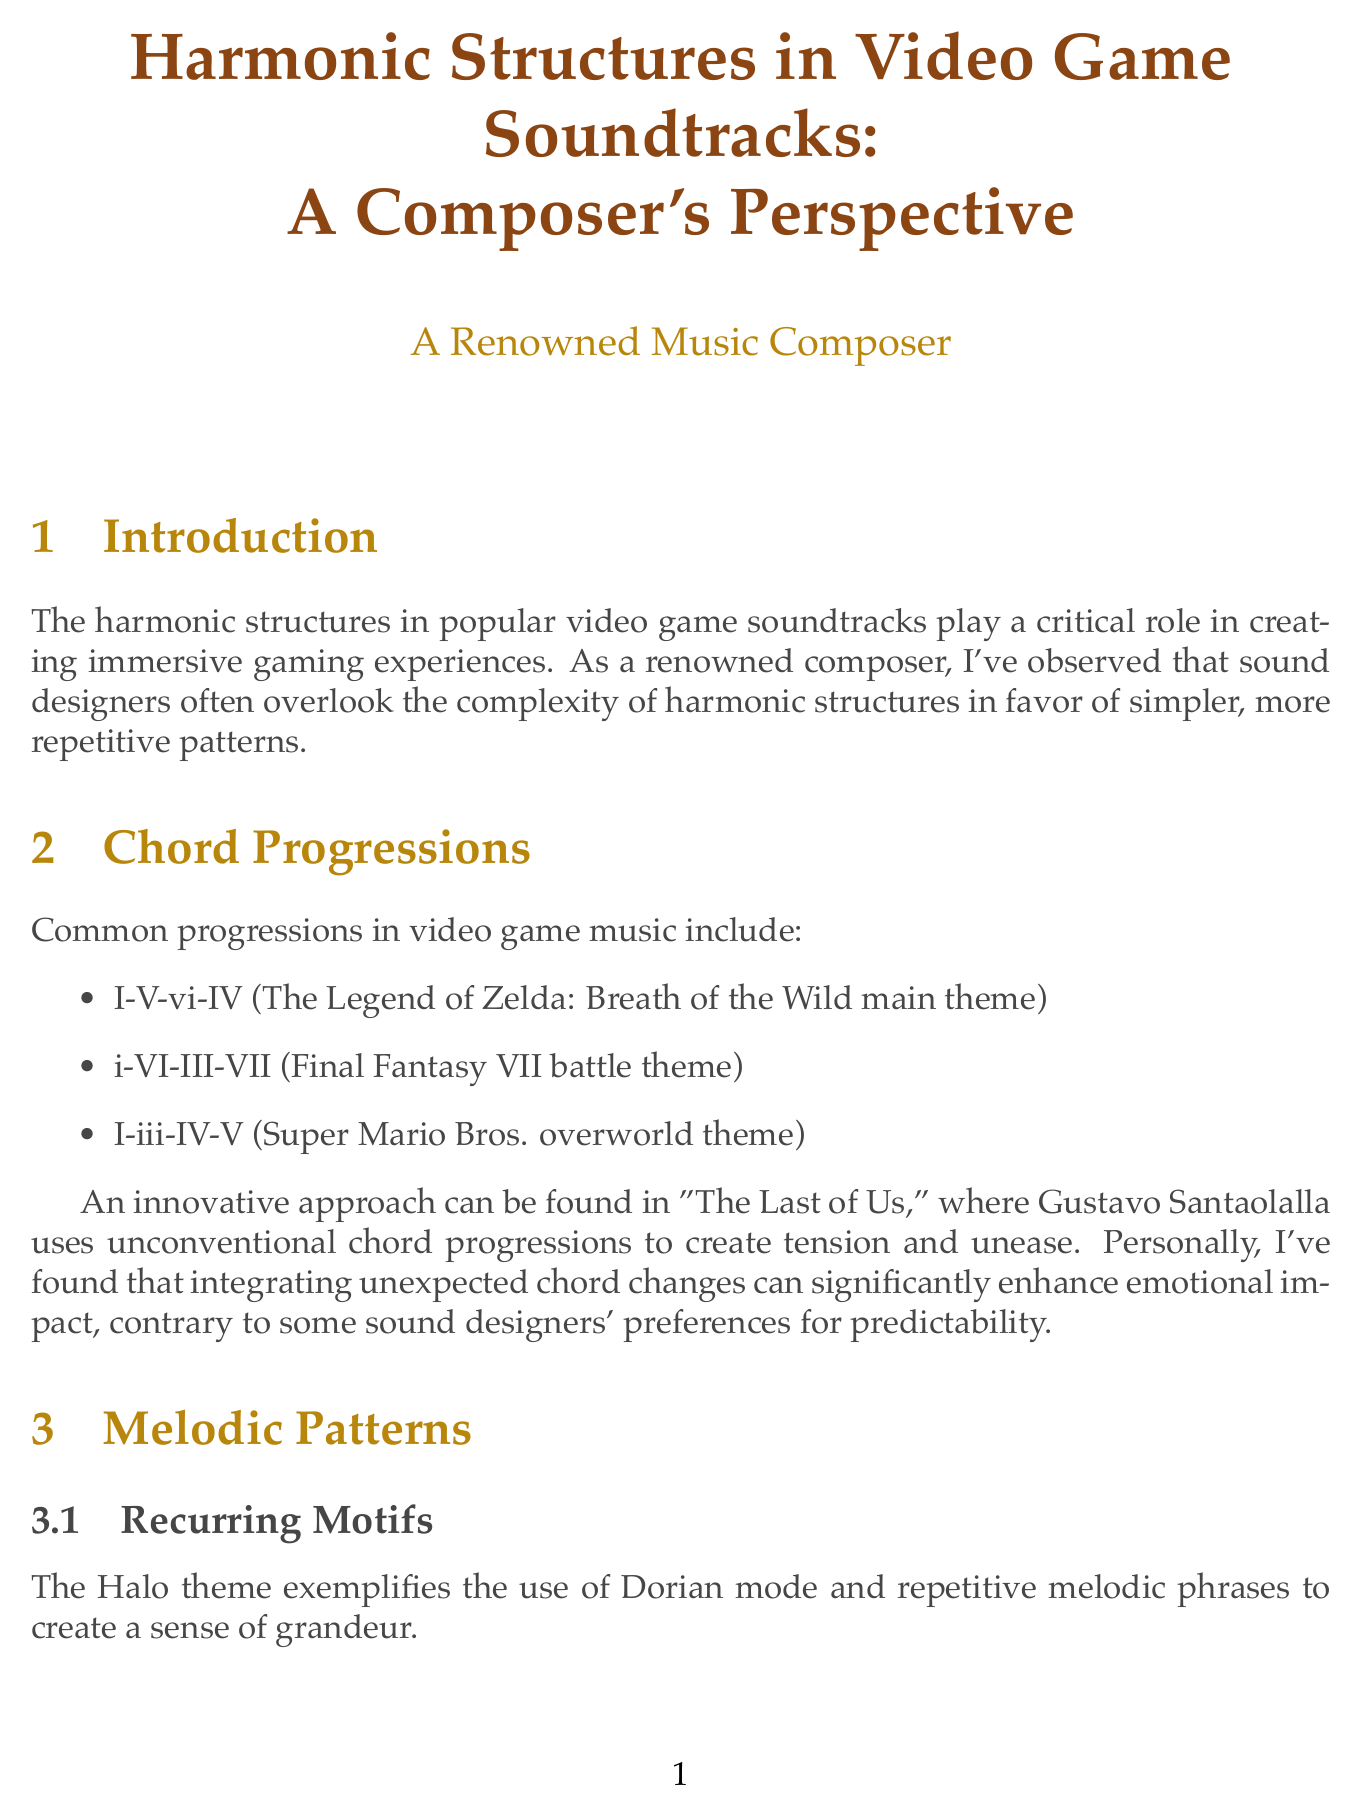What is the main topic of the report? The main topic of the report is presented in the introduction, emphasizing harmonic structures in popular video game soundtracks.
Answer: Harmonic structures in popular video game soundtracks Who composed the main theme for The Legend of Zelda: Breath of the Wild? The common chord progression example is based on the main theme of The Legend of Zelda: Breath of the Wild by its composer.
Answer: Unknown (not specified) What innovative approach is highlighted in "The Last of Us"? The document describes Gustavo Santaolalla's use of unconventional chord progressions as an innovative approach in "The Last of Us".
Answer: Unconventional chord progressions Which game features the Halo theme? The recurring motifs section specifically mentions the Halo theme as an example.
Answer: Halo What technique does Christopher Tin use in Civilization VI? The counterpoint section highlights the intricate counterpoint technique used by Christopher Tin in the main theme of Civilization VI.
Answer: Intricate counterpoint Which composer is associated with Nier: Automata? The extended harmonies section attributes the work in Nier: Automata to Keiichi Okabe.
Answer: Keiichi Okabe What is the conclusion's summary about harmonic structures? The conclusion summarizes the analysis of harmonic structures' impact on emotional storytelling and musical innovation.
Answer: A rich tapestry of musical innovation and emotional storytelling What future trend is mentioned in the conclusion? The report discusses future trends that include adaptive harmonies and AI-driven compositional techniques.
Answer: Adaptive harmonies and AI-driven compositional techniques 